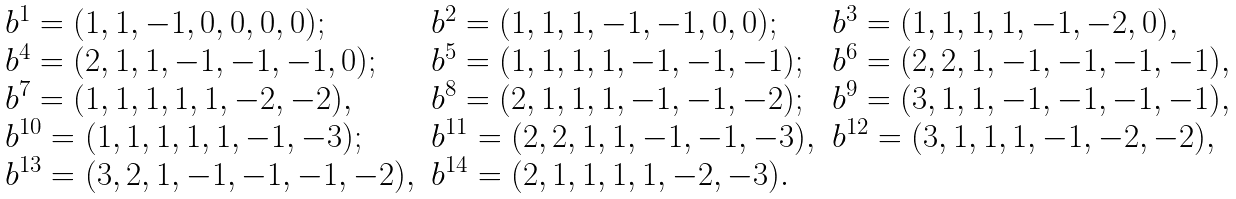Convert formula to latex. <formula><loc_0><loc_0><loc_500><loc_500>\begin{array} { l l l } b ^ { 1 } = ( 1 , 1 , - 1 , 0 , 0 , 0 , 0 ) ; & b ^ { 2 } = ( 1 , 1 , 1 , - 1 , - 1 , 0 , 0 ) ; & b ^ { 3 } = ( 1 , 1 , 1 , 1 , - 1 , - 2 , 0 ) , \\ b ^ { 4 } = ( 2 , 1 , 1 , - 1 , - 1 , - 1 , 0 ) ; & b ^ { 5 } = ( 1 , 1 , 1 , 1 , - 1 , - 1 , - 1 ) ; & b ^ { 6 } = ( 2 , 2 , 1 , - 1 , - 1 , - 1 , - 1 ) , \\ b ^ { 7 } = ( 1 , 1 , 1 , 1 , 1 , - 2 , - 2 ) , & b ^ { 8 } = ( 2 , 1 , 1 , 1 , - 1 , - 1 , - 2 ) ; & b ^ { 9 } = ( 3 , 1 , 1 , - 1 , - 1 , - 1 , - 1 ) , \\ b ^ { 1 0 } = ( 1 , 1 , 1 , 1 , 1 , - 1 , - 3 ) ; & b ^ { 1 1 } = ( 2 , 2 , 1 , 1 , - 1 , - 1 , - 3 ) , & b ^ { 1 2 } = ( 3 , 1 , 1 , 1 , - 1 , - 2 , - 2 ) , \\ b ^ { 1 3 } = ( 3 , 2 , 1 , - 1 , - 1 , - 1 , - 2 ) , & b ^ { 1 4 } = ( 2 , 1 , 1 , 1 , 1 , - 2 , - 3 ) . \end{array}</formula> 